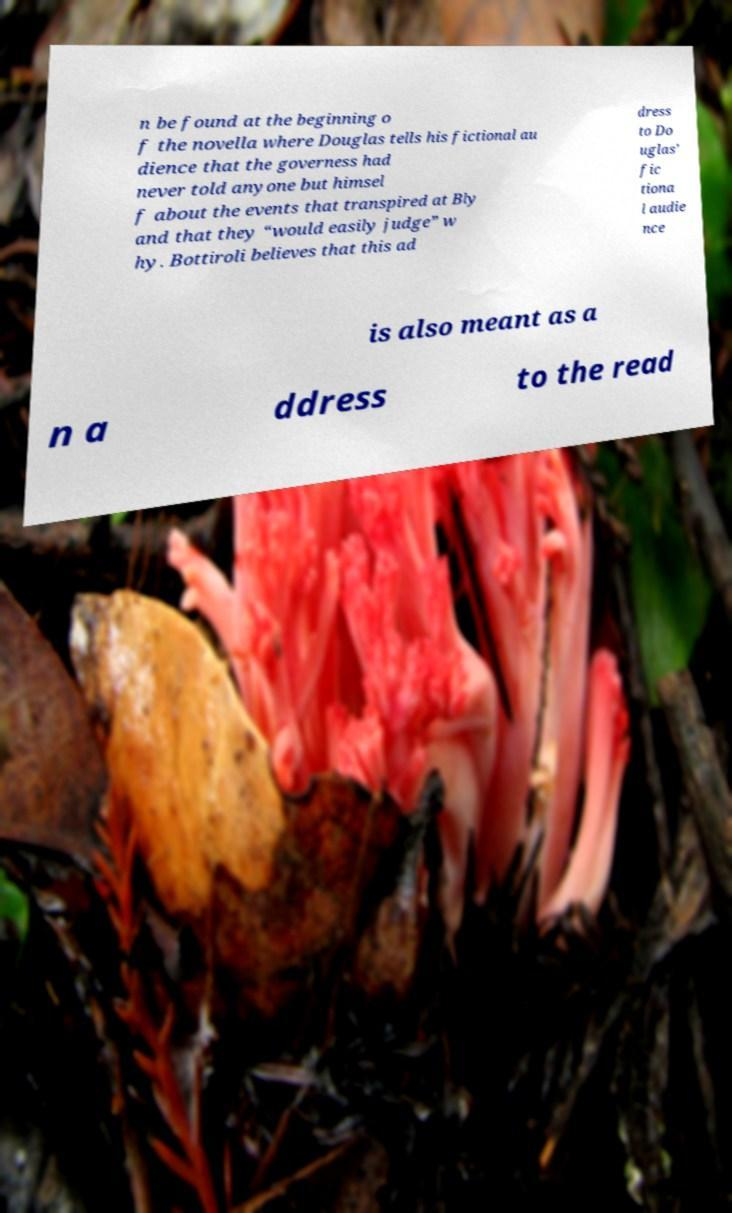I need the written content from this picture converted into text. Can you do that? n be found at the beginning o f the novella where Douglas tells his fictional au dience that the governess had never told anyone but himsel f about the events that transpired at Bly and that they “would easily judge” w hy. Bottiroli believes that this ad dress to Do uglas’ fic tiona l audie nce is also meant as a n a ddress to the read 